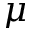<formula> <loc_0><loc_0><loc_500><loc_500>\mu</formula> 